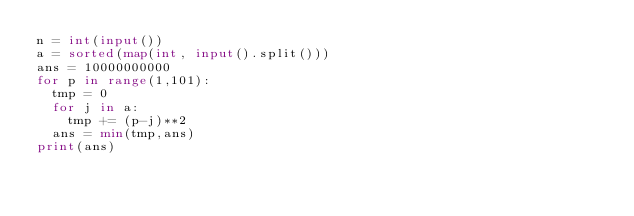<code> <loc_0><loc_0><loc_500><loc_500><_Python_>n = int(input())
a = sorted(map(int, input().split()))
ans = 10000000000
for p in range(1,101):
  tmp = 0
  for j in a:
    tmp += (p-j)**2
  ans = min(tmp,ans)
print(ans)</code> 